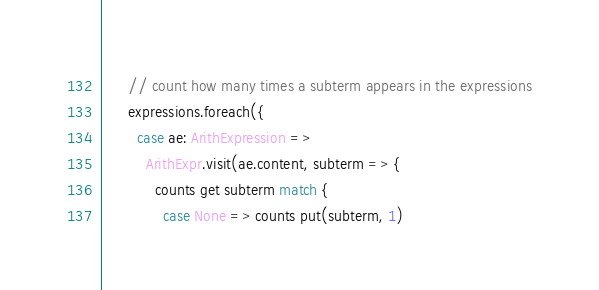Convert code to text. <code><loc_0><loc_0><loc_500><loc_500><_Scala_>
      // count how many times a subterm appears in the expressions
      expressions.foreach({
        case ae: ArithExpression =>
          ArithExpr.visit(ae.content, subterm => {
            counts get subterm match {
              case None => counts put(subterm, 1)</code> 